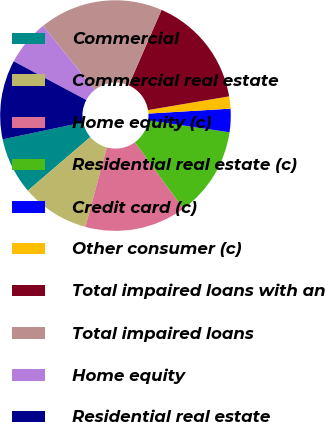Convert chart to OTSL. <chart><loc_0><loc_0><loc_500><loc_500><pie_chart><fcel>Commercial<fcel>Commercial real estate<fcel>Home equity (c)<fcel>Residential real estate (c)<fcel>Credit card (c)<fcel>Other consumer (c)<fcel>Total impaired loans with an<fcel>Total impaired loans<fcel>Home equity<fcel>Residential real estate<nl><fcel>7.97%<fcel>9.53%<fcel>14.22%<fcel>12.66%<fcel>3.27%<fcel>1.71%<fcel>15.79%<fcel>17.35%<fcel>6.4%<fcel>11.1%<nl></chart> 